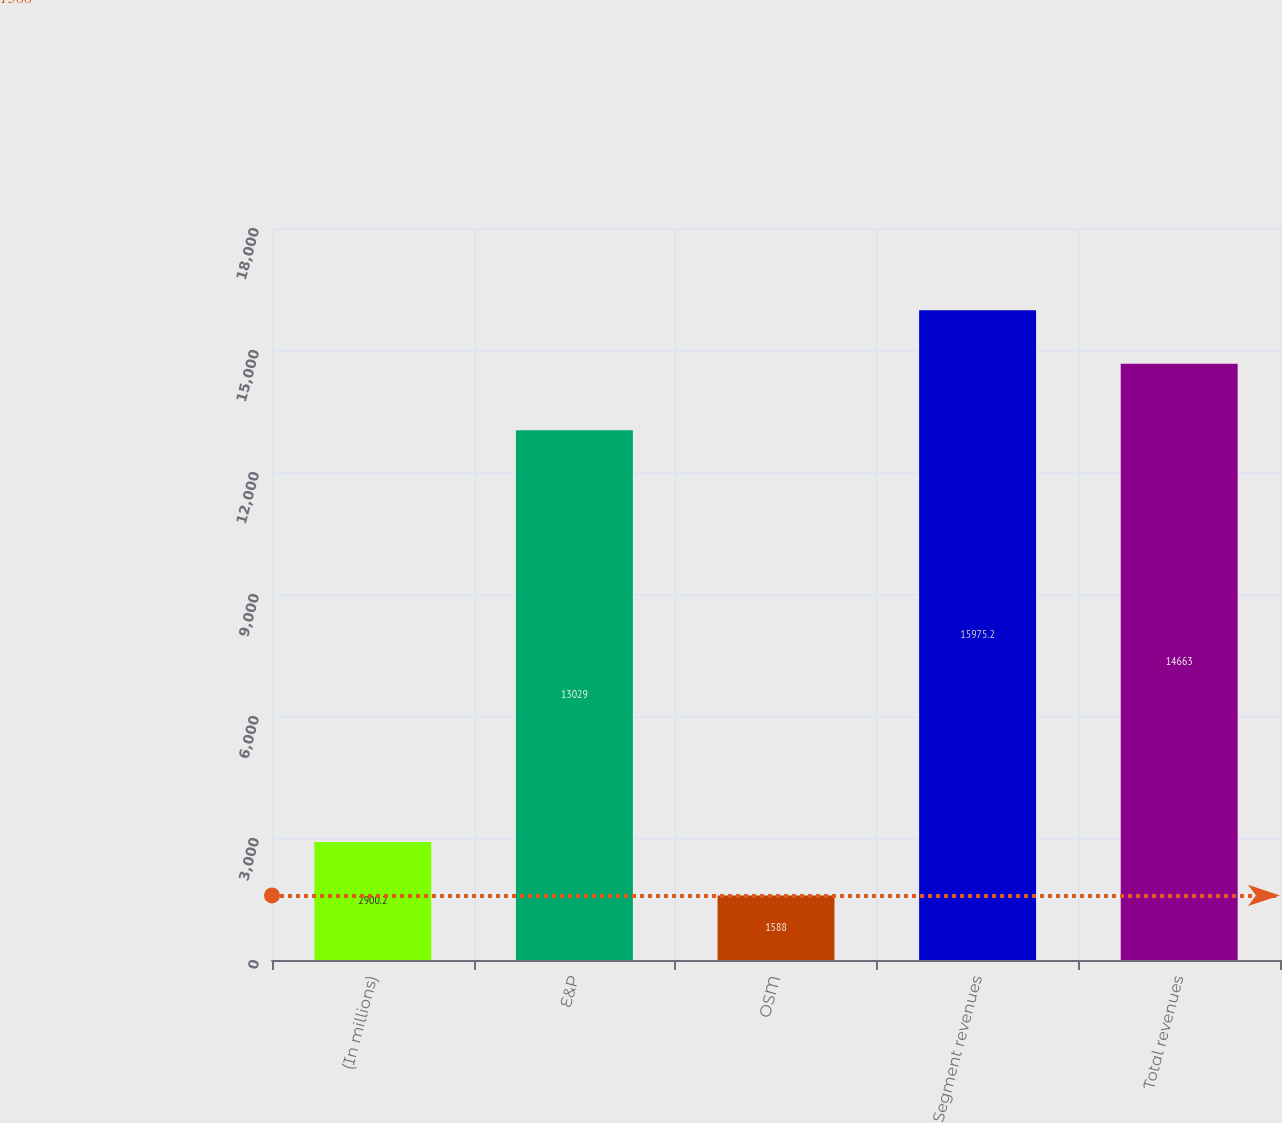Convert chart to OTSL. <chart><loc_0><loc_0><loc_500><loc_500><bar_chart><fcel>(In millions)<fcel>E&P<fcel>OSM<fcel>Segment revenues<fcel>Total revenues<nl><fcel>2900.2<fcel>13029<fcel>1588<fcel>15975.2<fcel>14663<nl></chart> 